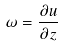Convert formula to latex. <formula><loc_0><loc_0><loc_500><loc_500>\omega = \frac { \partial u } { \partial z }</formula> 